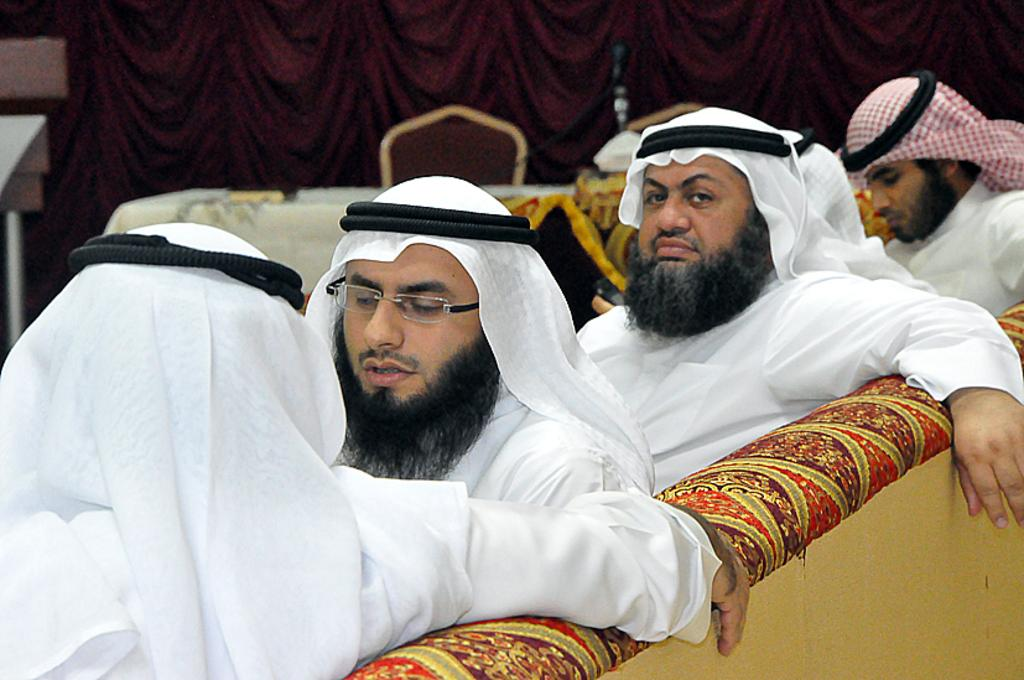How many people are in the image? There are four persons in the image. What are the persons doing in the image? The persons are sitting on a couch. What can be seen in the background of the image? There is a table, a chair, a curtain, and some objects in the background of the image. What type of business is being conducted in the image? There is no indication of any business being conducted in the image; the persons are simply sitting on a couch. 